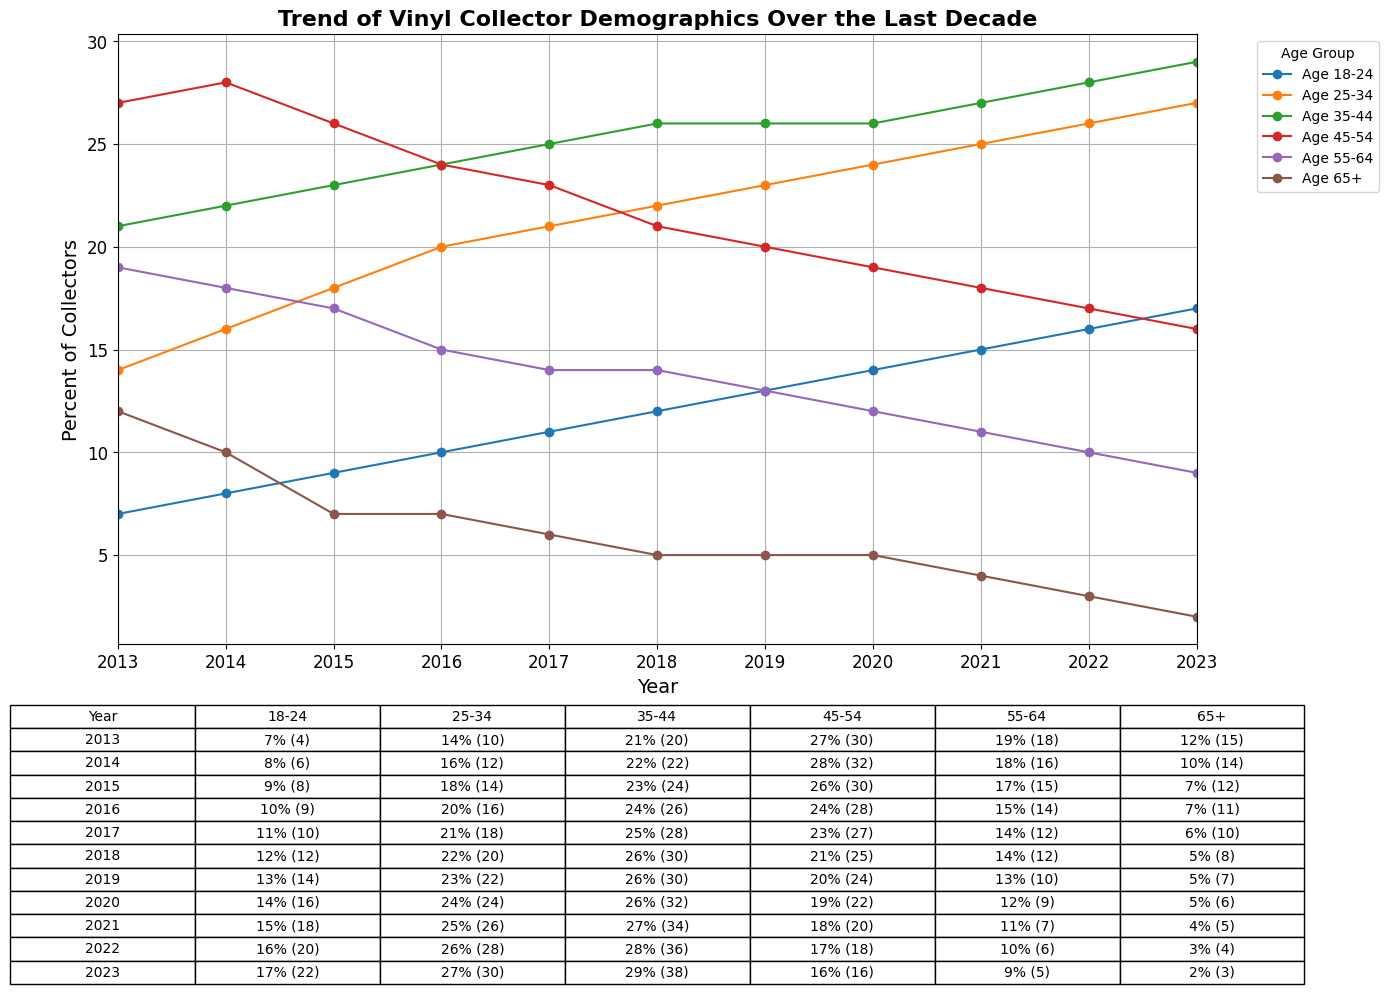what's the highest percentage of collectors in the 18-24 age group, and in which year was this recorded? To find the highest percentage in the 18-24 age group, look for the peak value in the trend line labeled "Age 18-24" in the plot. The highest percentage is 17% and can be found in the year 2023.
Answer: 17%, 2023 which age group had the highest annual purchase volume in 2022? To identify the age group with the highest annual purchase volume in 2022, locate the corresponding row in the table (2022) and compare the values in parentheses. The age group 35-44 had the highest annual purchase volume with 36.
Answer: 35-44 how did the percentage of collectors in the 25-34 age group change from 2013 to 2023? Compare the percentage values for the 25-34 age group in 2013 and 2023. In 2013, it was 14%, and in 2023, it was 27%. The change is 27% - 14% = 13%.
Answer: Increased by 13% what was the average annual purchase volume for the 45-54 age group from 2018 to 2023? Sum the annual purchase volumes for the 45-54 age group from 2018 to 2023 and then divide by the number of years. The volumes are 25, 24, 22, 20, 18, 16 = 125. The average is 125 / 6 ≈ 20.83.
Answer: 20.83 in which year did the 35-44 age group surpass the 45-54 age group in percentage of collectors? Compare the data lines for the 35-44 and 45-54 age groups. The 35-44 age group surpassed the 45-54 age group in 2017.
Answer: 2017 which age group had the steepest decline in percentage of collectors from 2013 to 2023? Find the difference in percentages from 2013 to 2023 for each age group and compare them. The 65+ age group had the steepest decline from 12% in 2013 to 2% in 2023, a decline of 10%.
Answer: 65+ is there any year where the percentage of collectors in the 55-64 age group increased compared to the previous year? Inspect the trend line for the 55-64 age group. The percentage never increased from one year to the next; it is either the same or decreased every year.
Answer: No which age group showed a consistent increase in both percentage of collectors and annual purchase volume over the decade? Check the trend lines for both metrics for each age group. The 18-24 age group shows a consistent increase in both percentage of collectors and annual purchase volume from 2013 to 2023.
Answer: 18-24 what is the total annual purchase volume for all age groups combined in 2016? Sum the annual purchase volumes for all age groups in 2016: 9+16+26+28+14+11 = 104.
Answer: 104 